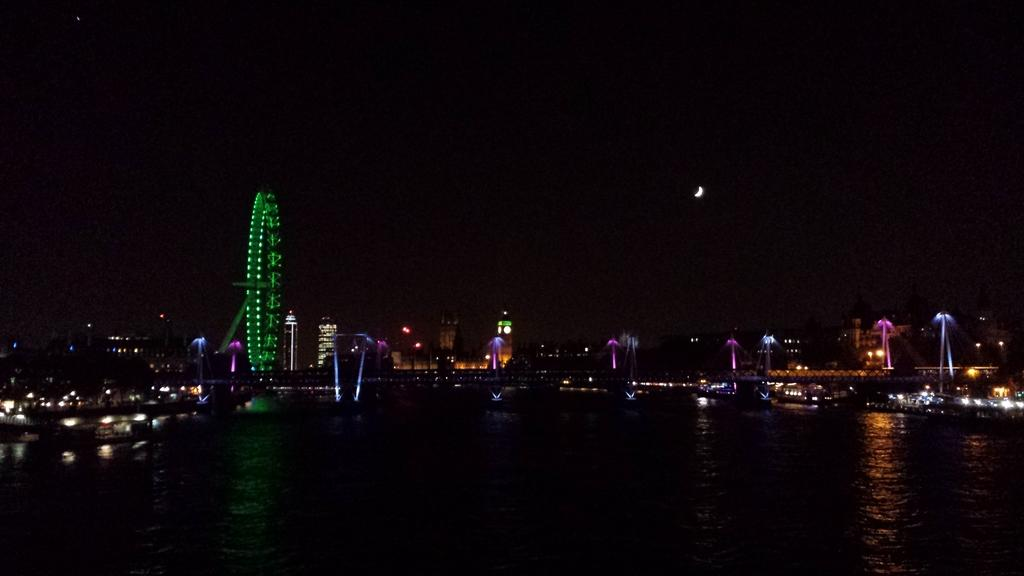What is the main feature in the image? There is a giant wheel in the image. What else can be seen in the image besides the giant wheel? There are buildings, lights, water, and the moon visible in the image. How is the background of the image described? The background of the image is dark. What type of van can be seen parked near the giant wheel in the image? There is no van present in the image. What kind of grain is being harvested near the water in the image? There is no grain or harvesting activity depicted in the image. 